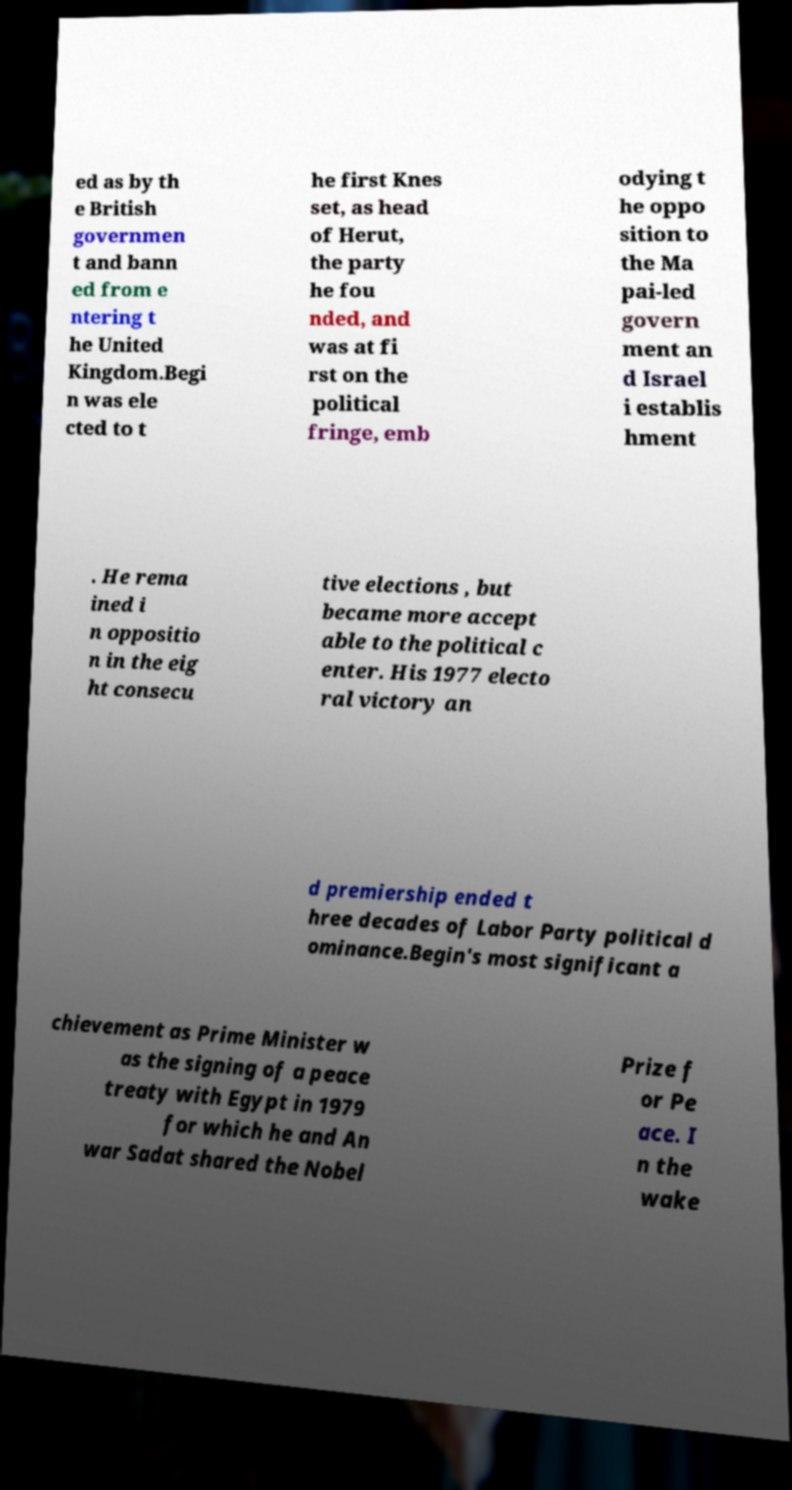Could you assist in decoding the text presented in this image and type it out clearly? ed as by th e British governmen t and bann ed from e ntering t he United Kingdom.Begi n was ele cted to t he first Knes set, as head of Herut, the party he fou nded, and was at fi rst on the political fringe, emb odying t he oppo sition to the Ma pai-led govern ment an d Israel i establis hment . He rema ined i n oppositio n in the eig ht consecu tive elections , but became more accept able to the political c enter. His 1977 electo ral victory an d premiership ended t hree decades of Labor Party political d ominance.Begin's most significant a chievement as Prime Minister w as the signing of a peace treaty with Egypt in 1979 for which he and An war Sadat shared the Nobel Prize f or Pe ace. I n the wake 